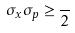<formula> <loc_0><loc_0><loc_500><loc_500>\sigma _ { x } \sigma _ { p } \geq \frac { } { 2 }</formula> 